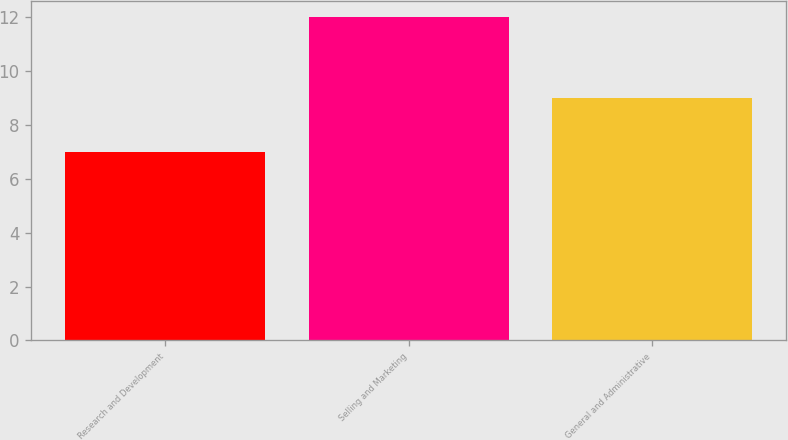Convert chart. <chart><loc_0><loc_0><loc_500><loc_500><bar_chart><fcel>Research and Development<fcel>Selling and Marketing<fcel>General and Administrative<nl><fcel>7<fcel>12<fcel>9<nl></chart> 